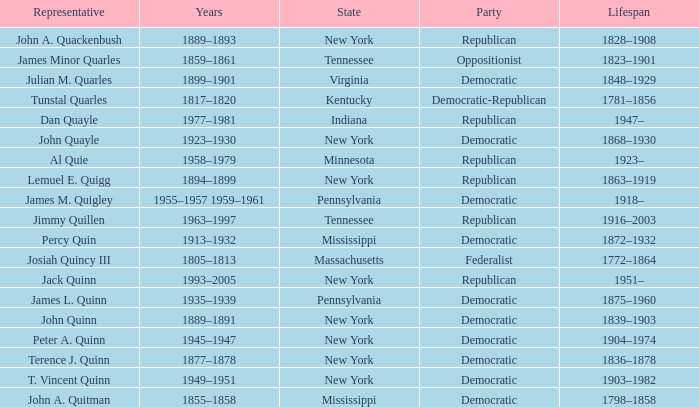Which party has Peter A. Quinn as a representative? Democratic. 